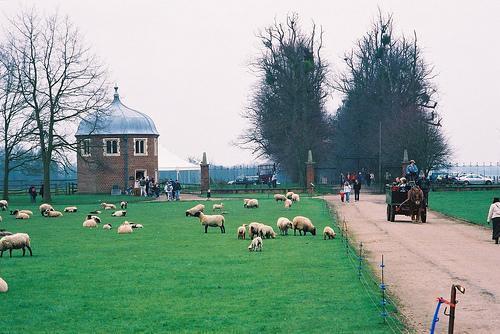How many barns are there?
Give a very brief answer. 1. How many cars are visible?
Give a very brief answer. 1. 